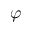Convert formula to latex. <formula><loc_0><loc_0><loc_500><loc_500>\varphi</formula> 